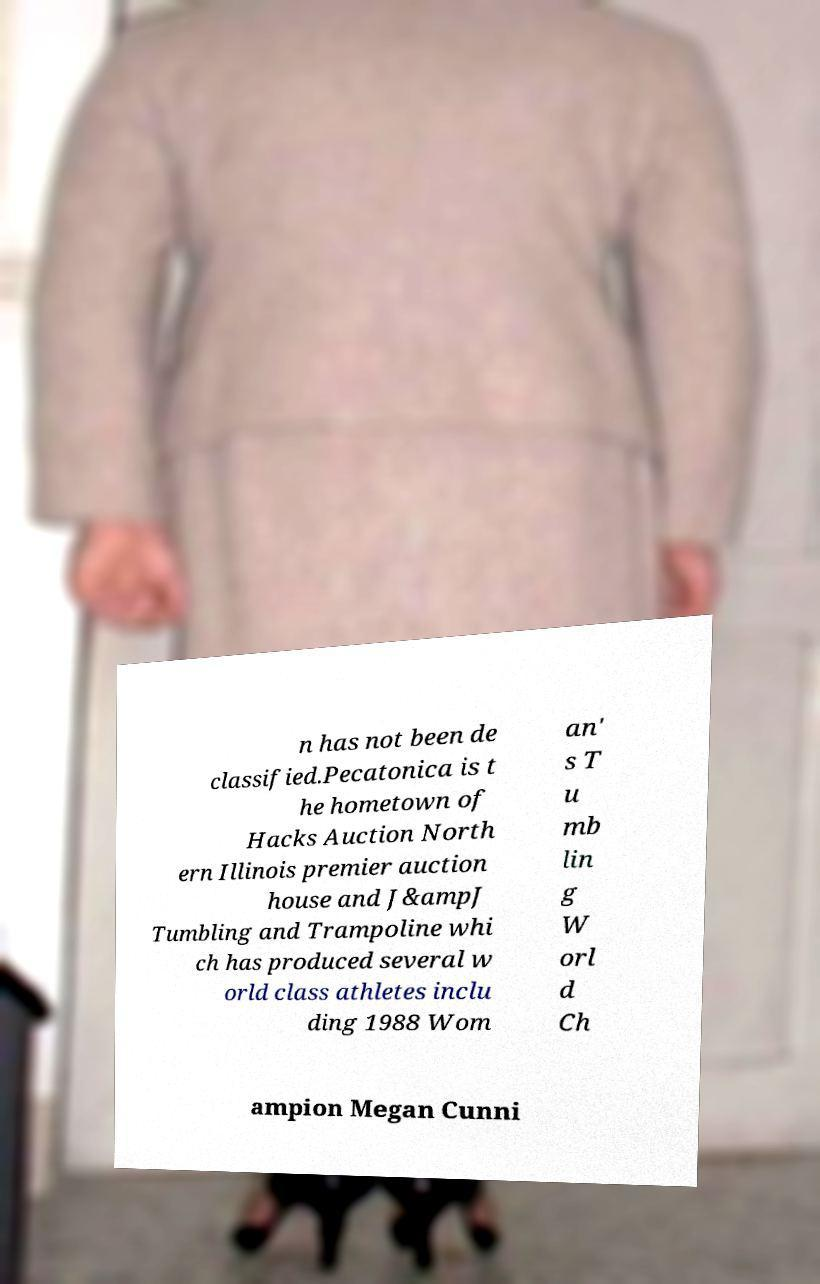Please read and relay the text visible in this image. What does it say? n has not been de classified.Pecatonica is t he hometown of Hacks Auction North ern Illinois premier auction house and J&ampJ Tumbling and Trampoline whi ch has produced several w orld class athletes inclu ding 1988 Wom an' s T u mb lin g W orl d Ch ampion Megan Cunni 